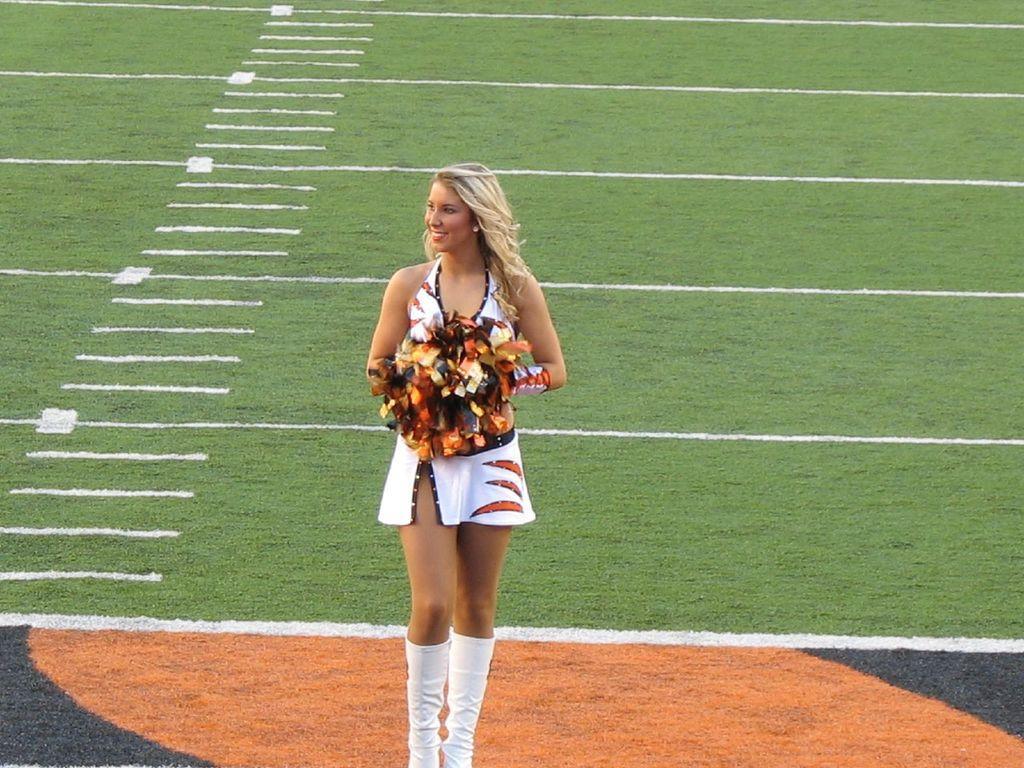Could you give a brief overview of what you see in this image? There is a woman holding glitter flowers in the foreground area of the image, it seems like a ground. 